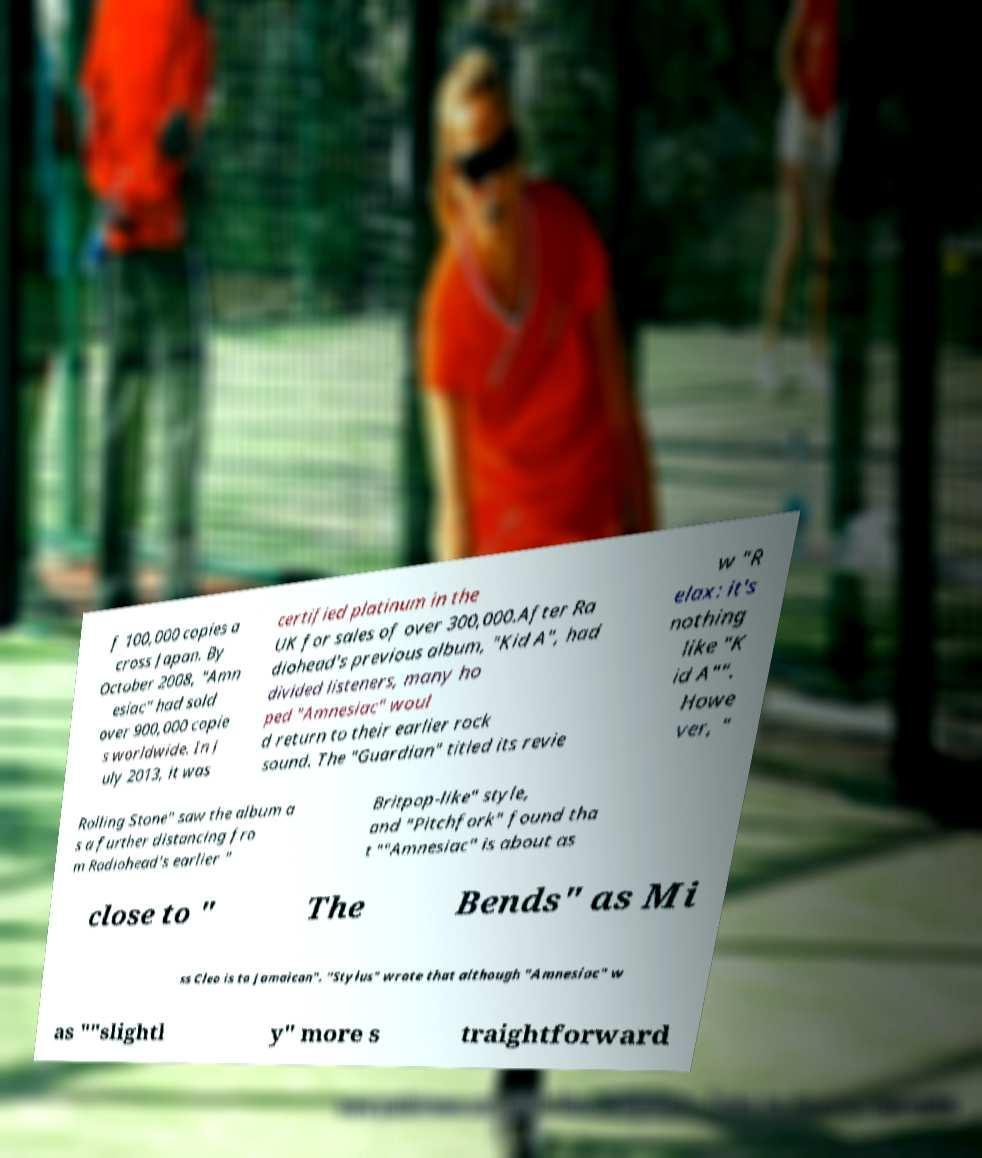I need the written content from this picture converted into text. Can you do that? f 100,000 copies a cross Japan. By October 2008, "Amn esiac" had sold over 900,000 copie s worldwide. In J uly 2013, it was certified platinum in the UK for sales of over 300,000.After Ra diohead's previous album, "Kid A", had divided listeners, many ho ped "Amnesiac" woul d return to their earlier rock sound. The "Guardian" titled its revie w "R elax: it's nothing like "K id A"". Howe ver, " Rolling Stone" saw the album a s a further distancing fro m Radiohead's earlier " Britpop-like" style, and "Pitchfork" found tha t ""Amnesiac" is about as close to " The Bends" as Mi ss Cleo is to Jamaican". "Stylus" wrote that although "Amnesiac" w as ""slightl y" more s traightforward 